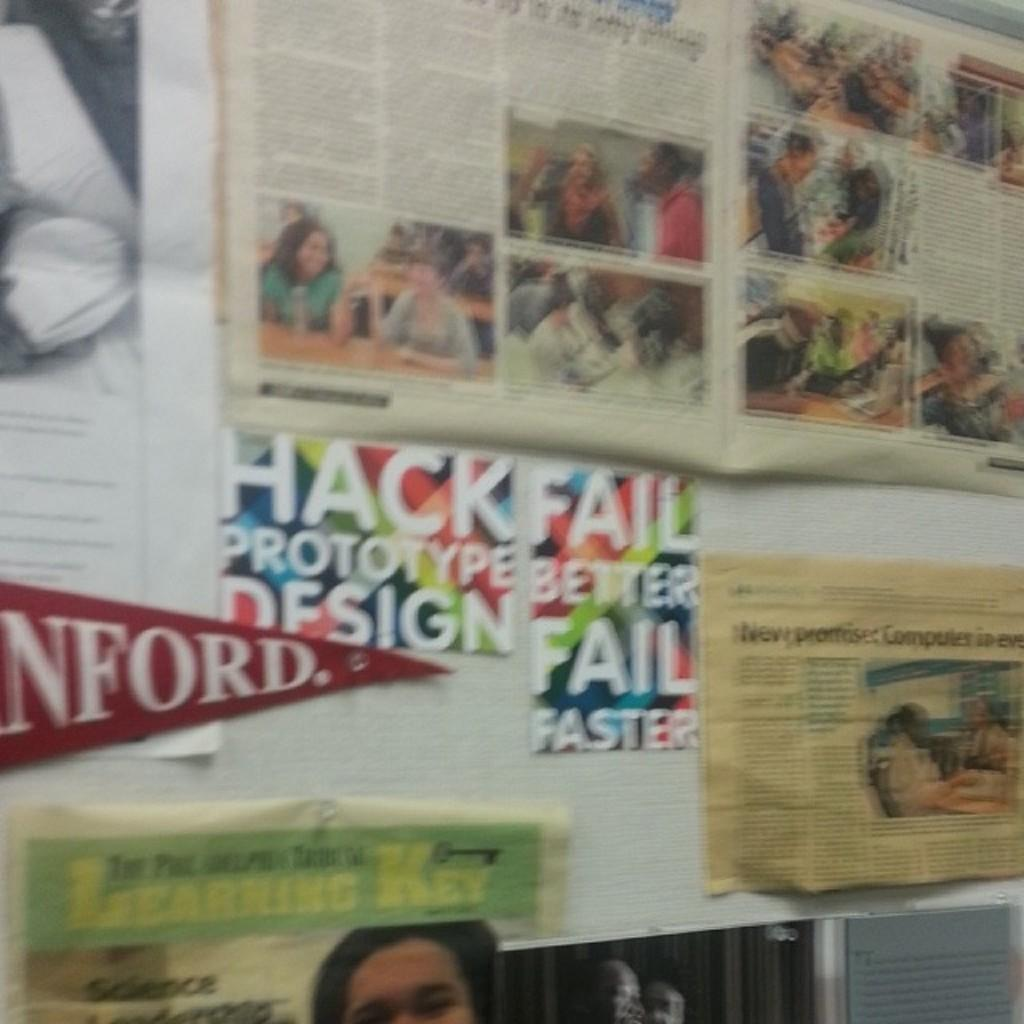<image>
Provide a brief description of the given image. A red Stanford college banner is partially visible hanging on the wall. 